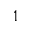Convert formula to latex. <formula><loc_0><loc_0><loc_500><loc_500>1</formula> 